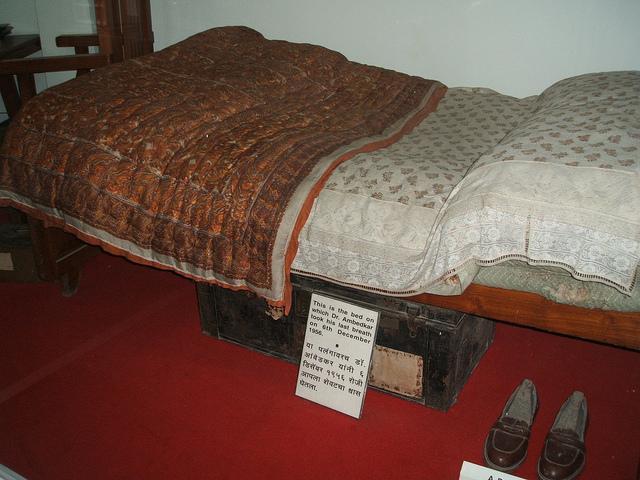How many women are sitting down?
Give a very brief answer. 0. 